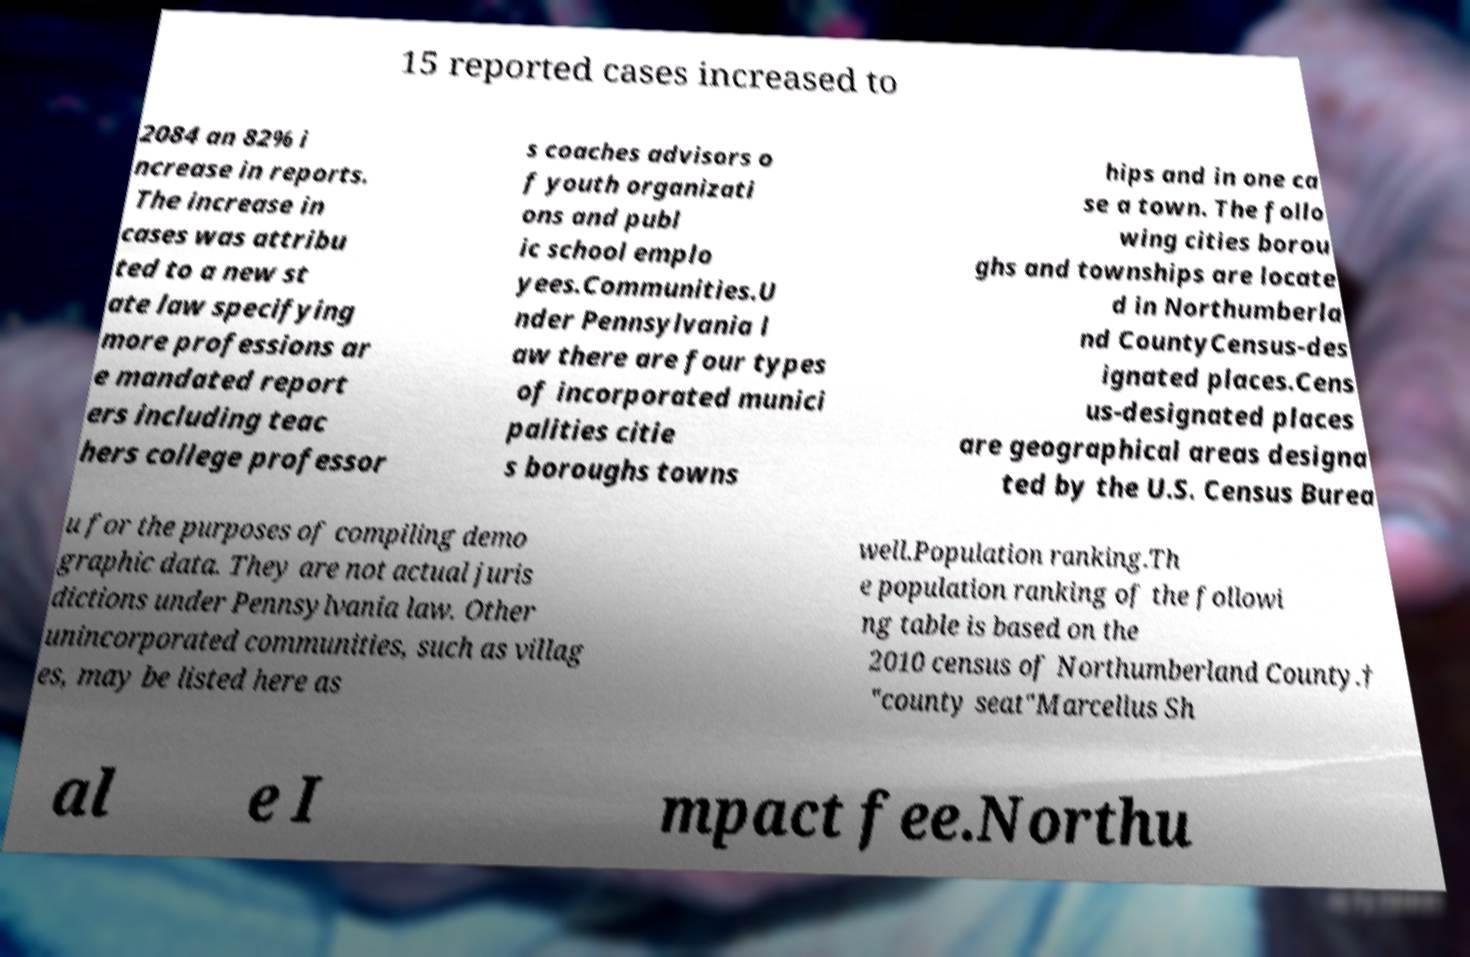There's text embedded in this image that I need extracted. Can you transcribe it verbatim? 15 reported cases increased to 2084 an 82% i ncrease in reports. The increase in cases was attribu ted to a new st ate law specifying more professions ar e mandated report ers including teac hers college professor s coaches advisors o f youth organizati ons and publ ic school emplo yees.Communities.U nder Pennsylvania l aw there are four types of incorporated munici palities citie s boroughs towns hips and in one ca se a town. The follo wing cities borou ghs and townships are locate d in Northumberla nd CountyCensus-des ignated places.Cens us-designated places are geographical areas designa ted by the U.S. Census Burea u for the purposes of compiling demo graphic data. They are not actual juris dictions under Pennsylvania law. Other unincorporated communities, such as villag es, may be listed here as well.Population ranking.Th e population ranking of the followi ng table is based on the 2010 census of Northumberland County.† "county seat"Marcellus Sh al e I mpact fee.Northu 